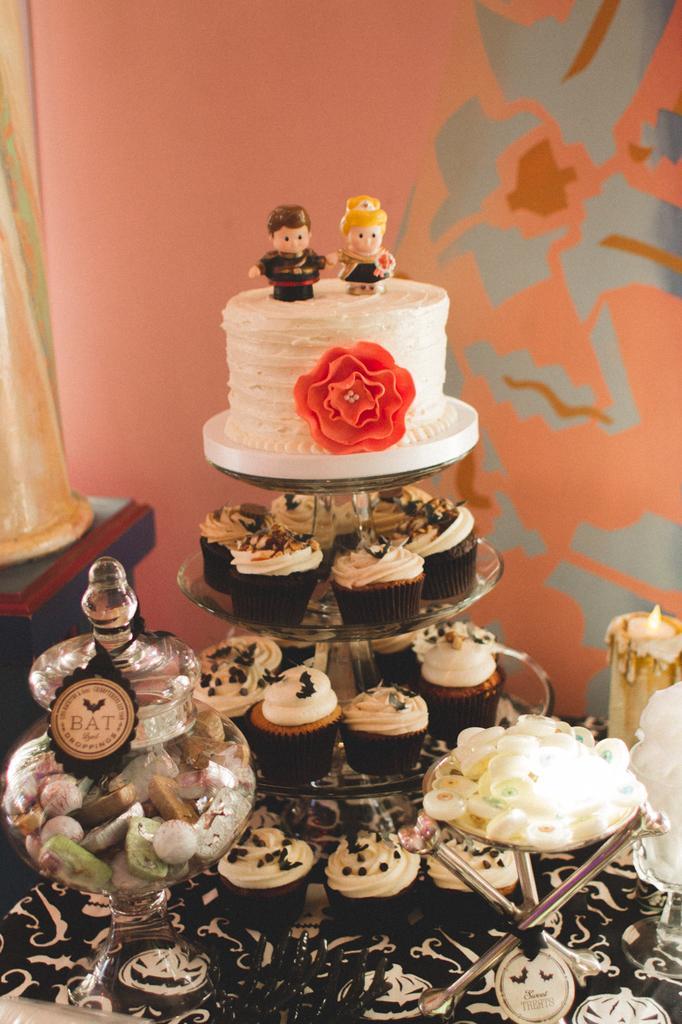Can you describe this image briefly? In this image we can see there is a table, on the table there is a glass jar, stand, candle and some food items on it. At the side there is a pillar. And at the back there is a wall with a design. 